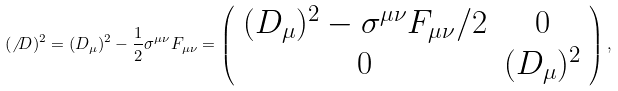<formula> <loc_0><loc_0><loc_500><loc_500>( { \not \, D } ) ^ { 2 } = ( D _ { \mu } ) ^ { 2 } - \frac { 1 } { 2 } \sigma ^ { \mu \nu } F _ { \mu \nu } = \left ( \begin{array} { c c } ( D _ { \mu } ) ^ { 2 } - \sigma ^ { \mu \nu } F _ { \mu \nu } / 2 & 0 \\ 0 & ( D _ { \mu } ) ^ { 2 } \end{array} \right ) ,</formula> 